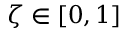<formula> <loc_0><loc_0><loc_500><loc_500>\zeta \in [ 0 , 1 ]</formula> 